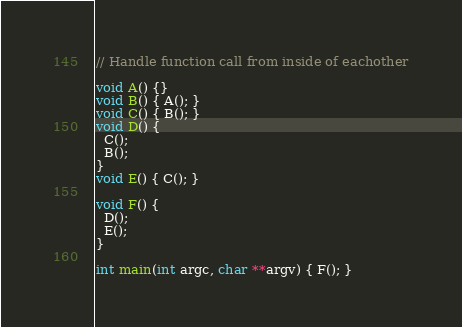Convert code to text. <code><loc_0><loc_0><loc_500><loc_500><_C++_>// Handle function call from inside of eachother

void A() {}
void B() { A(); }
void C() { B(); }
void D() {
  C();
  B();
}
void E() { C(); }

void F() {
  D();
  E();
}

int main(int argc, char **argv) { F(); }</code> 